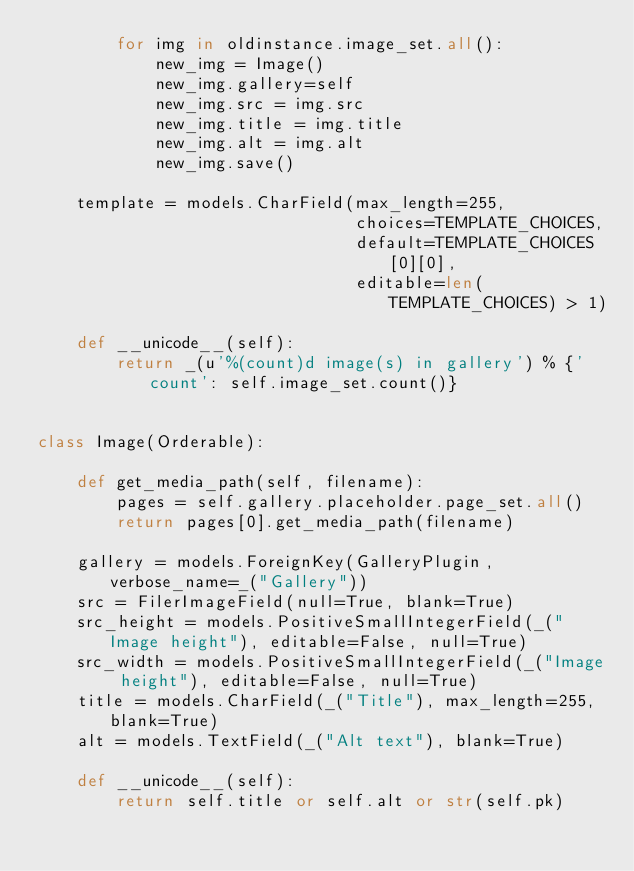<code> <loc_0><loc_0><loc_500><loc_500><_Python_>        for img in oldinstance.image_set.all():
            new_img = Image()
            new_img.gallery=self
            new_img.src = img.src
            new_img.title = img.title
            new_img.alt = img.alt
            new_img.save()

    template = models.CharField(max_length=255,
                                choices=TEMPLATE_CHOICES,
                                default=TEMPLATE_CHOICES[0][0],
                                editable=len(TEMPLATE_CHOICES) > 1)

    def __unicode__(self):
        return _(u'%(count)d image(s) in gallery') % {'count': self.image_set.count()}


class Image(Orderable):

    def get_media_path(self, filename):
        pages = self.gallery.placeholder.page_set.all()
        return pages[0].get_media_path(filename)

    gallery = models.ForeignKey(GalleryPlugin, verbose_name=_("Gallery"))
    src = FilerImageField(null=True, blank=True)
    src_height = models.PositiveSmallIntegerField(_("Image height"), editable=False, null=True)
    src_width = models.PositiveSmallIntegerField(_("Image height"), editable=False, null=True)
    title = models.CharField(_("Title"), max_length=255, blank=True)
    alt = models.TextField(_("Alt text"), blank=True)

    def __unicode__(self):
        return self.title or self.alt or str(self.pk)
</code> 